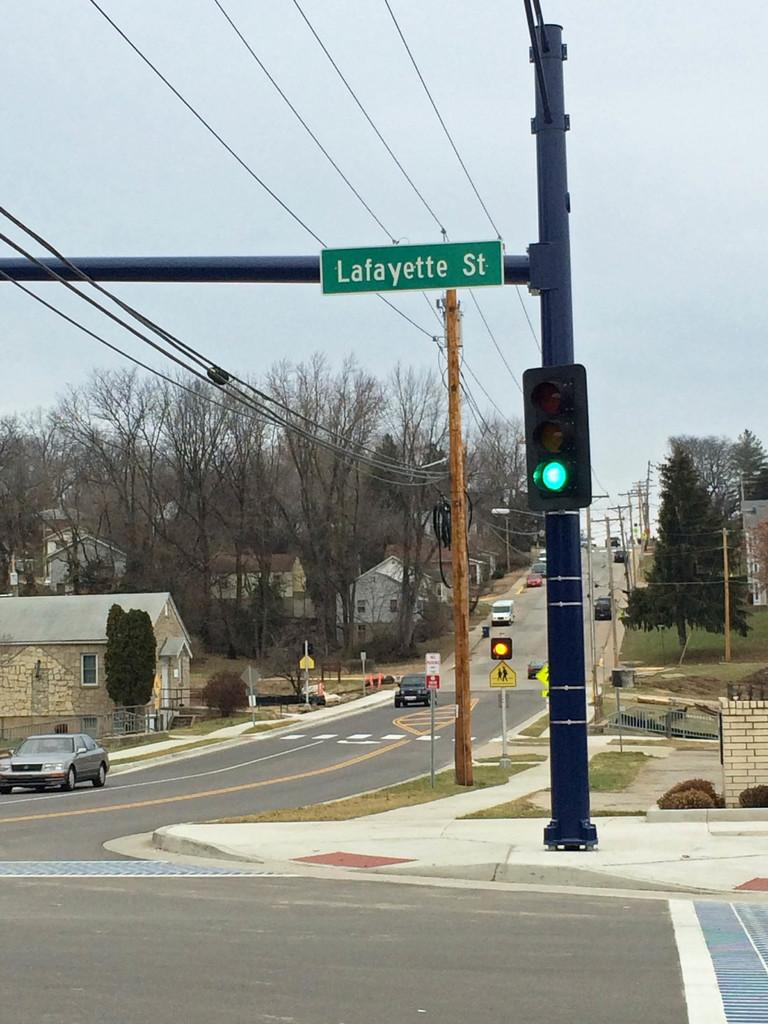<image>
Give a short and clear explanation of the subsequent image. A cross section of Lafayette street with few cars on the road. 